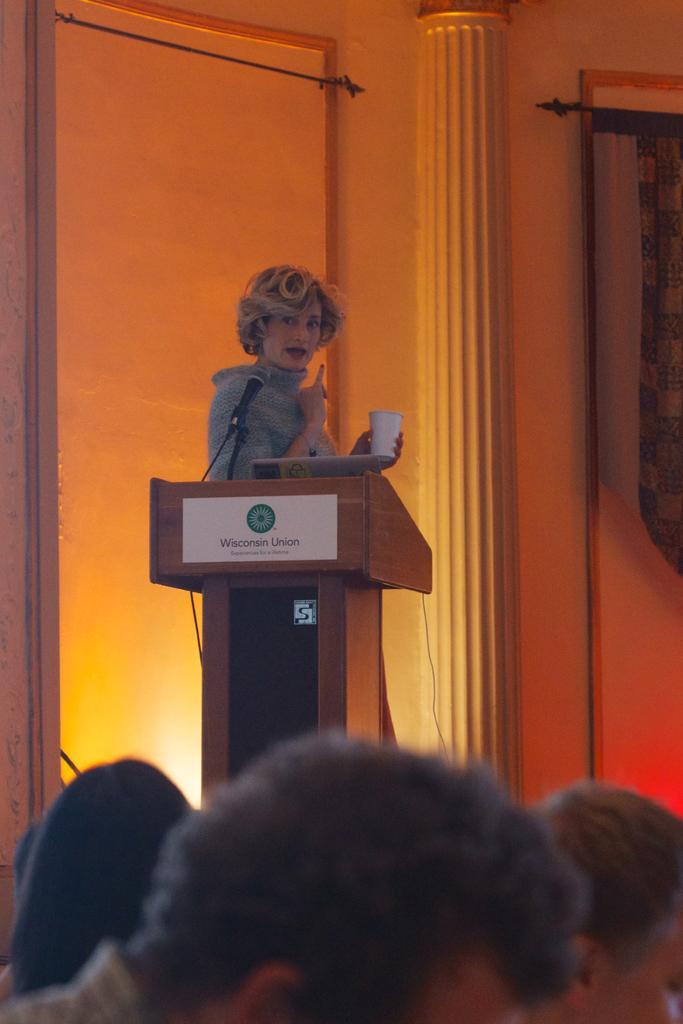Could you give a brief overview of what you see in this image? There are persons. In the background, there is a woman, holding a white color cup with one hand and standing in front of a stand on which, there is a poster and a mic which is attached to the stand, there is a pillar and there is wall. 